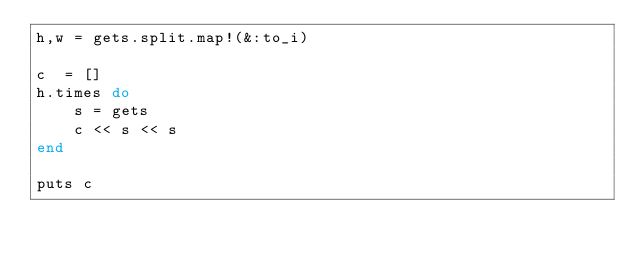Convert code to text. <code><loc_0><loc_0><loc_500><loc_500><_Ruby_>h,w = gets.split.map!(&:to_i)

c  = []
h.times do 
    s = gets
    c << s << s
end

puts c</code> 